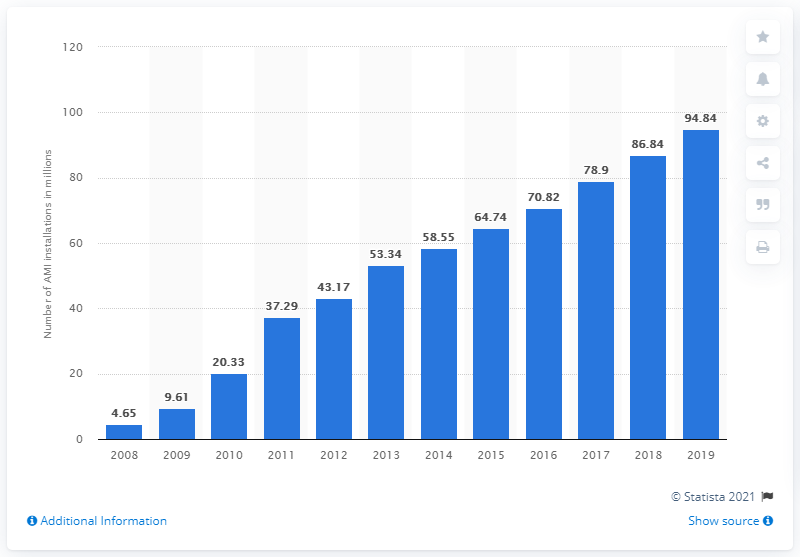Mention a couple of crucial points in this snapshot. In 2019, a total of 94.84 advanced meters were distributed among households and industrial customers. 